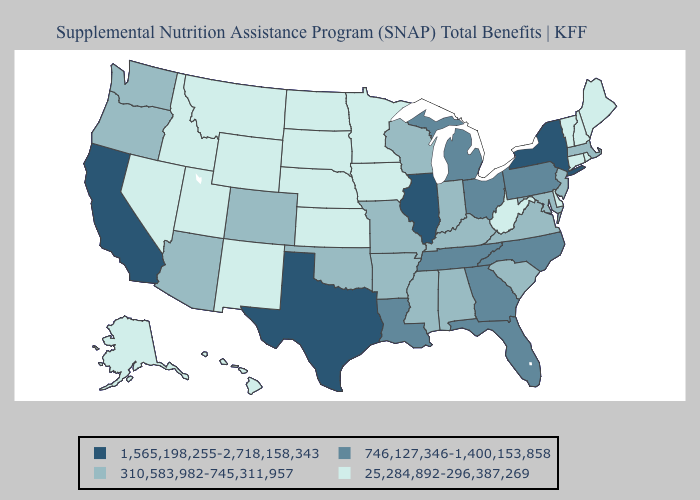Among the states that border New Mexico , does Utah have the highest value?
Give a very brief answer. No. Does Arizona have the lowest value in the USA?
Give a very brief answer. No. Which states hav the highest value in the Northeast?
Write a very short answer. New York. What is the value of South Carolina?
Short answer required. 310,583,982-745,311,957. What is the value of Virginia?
Write a very short answer. 310,583,982-745,311,957. What is the value of Arizona?
Answer briefly. 310,583,982-745,311,957. What is the value of Colorado?
Quick response, please. 310,583,982-745,311,957. How many symbols are there in the legend?
Quick response, please. 4. Name the states that have a value in the range 25,284,892-296,387,269?
Write a very short answer. Alaska, Connecticut, Delaware, Hawaii, Idaho, Iowa, Kansas, Maine, Minnesota, Montana, Nebraska, Nevada, New Hampshire, New Mexico, North Dakota, Rhode Island, South Dakota, Utah, Vermont, West Virginia, Wyoming. What is the lowest value in the South?
Quick response, please. 25,284,892-296,387,269. Name the states that have a value in the range 25,284,892-296,387,269?
Concise answer only. Alaska, Connecticut, Delaware, Hawaii, Idaho, Iowa, Kansas, Maine, Minnesota, Montana, Nebraska, Nevada, New Hampshire, New Mexico, North Dakota, Rhode Island, South Dakota, Utah, Vermont, West Virginia, Wyoming. What is the value of North Carolina?
Give a very brief answer. 746,127,346-1,400,153,858. Does South Dakota have a lower value than New Mexico?
Keep it brief. No. Which states have the highest value in the USA?
Keep it brief. California, Illinois, New York, Texas. Among the states that border Missouri , does Kansas have the highest value?
Concise answer only. No. 